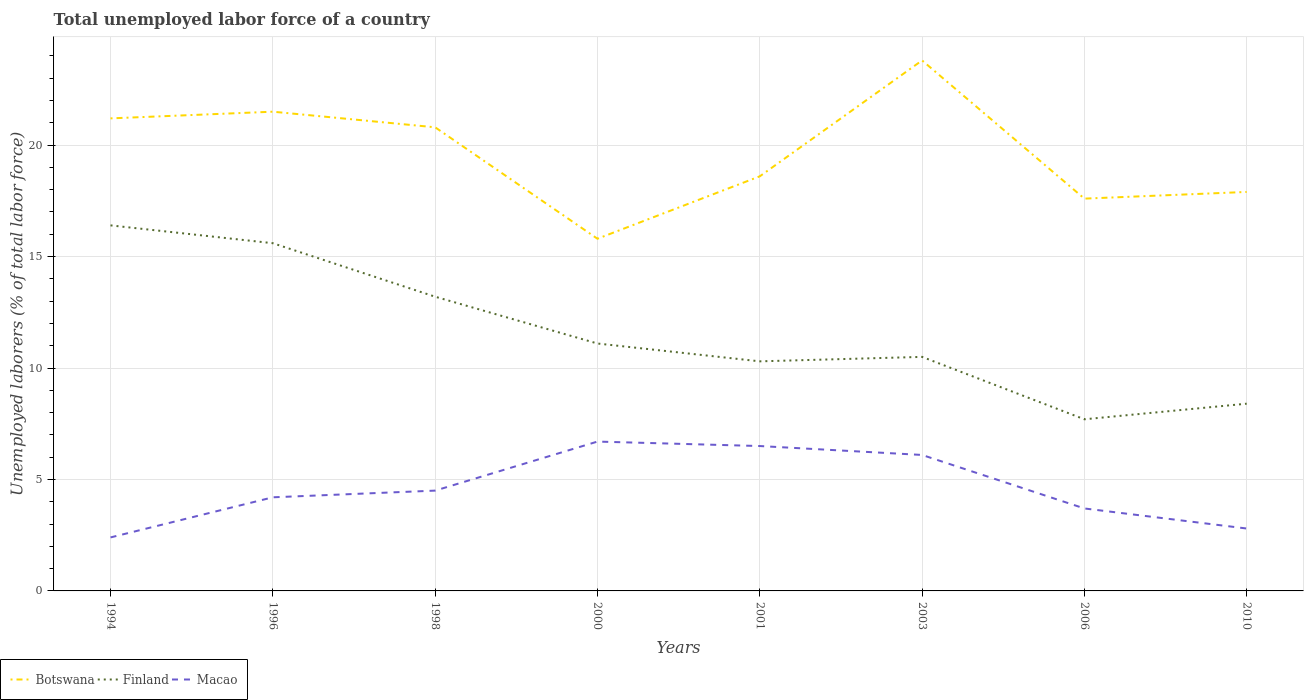Across all years, what is the maximum total unemployed labor force in Macao?
Provide a short and direct response. 2.4. What is the total total unemployed labor force in Botswana in the graph?
Your answer should be very brief. -2.1. What is the difference between the highest and the second highest total unemployed labor force in Finland?
Keep it short and to the point. 8.7. What is the difference between two consecutive major ticks on the Y-axis?
Keep it short and to the point. 5. Are the values on the major ticks of Y-axis written in scientific E-notation?
Offer a terse response. No. Where does the legend appear in the graph?
Ensure brevity in your answer.  Bottom left. What is the title of the graph?
Provide a succinct answer. Total unemployed labor force of a country. What is the label or title of the X-axis?
Your answer should be very brief. Years. What is the label or title of the Y-axis?
Your answer should be very brief. Unemployed laborers (% of total labor force). What is the Unemployed laborers (% of total labor force) of Botswana in 1994?
Offer a terse response. 21.2. What is the Unemployed laborers (% of total labor force) in Finland in 1994?
Offer a terse response. 16.4. What is the Unemployed laborers (% of total labor force) of Macao in 1994?
Give a very brief answer. 2.4. What is the Unemployed laborers (% of total labor force) of Finland in 1996?
Your answer should be compact. 15.6. What is the Unemployed laborers (% of total labor force) in Macao in 1996?
Give a very brief answer. 4.2. What is the Unemployed laborers (% of total labor force) of Botswana in 1998?
Offer a very short reply. 20.8. What is the Unemployed laborers (% of total labor force) in Finland in 1998?
Ensure brevity in your answer.  13.2. What is the Unemployed laborers (% of total labor force) of Macao in 1998?
Provide a succinct answer. 4.5. What is the Unemployed laborers (% of total labor force) in Botswana in 2000?
Offer a very short reply. 15.8. What is the Unemployed laborers (% of total labor force) of Finland in 2000?
Give a very brief answer. 11.1. What is the Unemployed laborers (% of total labor force) of Macao in 2000?
Offer a terse response. 6.7. What is the Unemployed laborers (% of total labor force) in Botswana in 2001?
Provide a short and direct response. 18.6. What is the Unemployed laborers (% of total labor force) of Finland in 2001?
Provide a succinct answer. 10.3. What is the Unemployed laborers (% of total labor force) in Macao in 2001?
Provide a short and direct response. 6.5. What is the Unemployed laborers (% of total labor force) in Botswana in 2003?
Your answer should be compact. 23.8. What is the Unemployed laborers (% of total labor force) in Macao in 2003?
Provide a succinct answer. 6.1. What is the Unemployed laborers (% of total labor force) of Botswana in 2006?
Offer a very short reply. 17.6. What is the Unemployed laborers (% of total labor force) of Finland in 2006?
Make the answer very short. 7.7. What is the Unemployed laborers (% of total labor force) of Macao in 2006?
Give a very brief answer. 3.7. What is the Unemployed laborers (% of total labor force) of Botswana in 2010?
Your answer should be compact. 17.9. What is the Unemployed laborers (% of total labor force) in Finland in 2010?
Your answer should be very brief. 8.4. What is the Unemployed laborers (% of total labor force) of Macao in 2010?
Provide a short and direct response. 2.8. Across all years, what is the maximum Unemployed laborers (% of total labor force) of Botswana?
Provide a succinct answer. 23.8. Across all years, what is the maximum Unemployed laborers (% of total labor force) of Finland?
Give a very brief answer. 16.4. Across all years, what is the maximum Unemployed laborers (% of total labor force) in Macao?
Make the answer very short. 6.7. Across all years, what is the minimum Unemployed laborers (% of total labor force) in Botswana?
Give a very brief answer. 15.8. Across all years, what is the minimum Unemployed laborers (% of total labor force) of Finland?
Provide a succinct answer. 7.7. Across all years, what is the minimum Unemployed laborers (% of total labor force) in Macao?
Offer a terse response. 2.4. What is the total Unemployed laborers (% of total labor force) of Botswana in the graph?
Offer a very short reply. 157.2. What is the total Unemployed laborers (% of total labor force) of Finland in the graph?
Offer a very short reply. 93.2. What is the total Unemployed laborers (% of total labor force) of Macao in the graph?
Provide a short and direct response. 36.9. What is the difference between the Unemployed laborers (% of total labor force) of Finland in 1994 and that in 1996?
Your answer should be very brief. 0.8. What is the difference between the Unemployed laborers (% of total labor force) of Macao in 1994 and that in 1996?
Your answer should be compact. -1.8. What is the difference between the Unemployed laborers (% of total labor force) in Botswana in 1994 and that in 1998?
Keep it short and to the point. 0.4. What is the difference between the Unemployed laborers (% of total labor force) of Finland in 1994 and that in 1998?
Give a very brief answer. 3.2. What is the difference between the Unemployed laborers (% of total labor force) of Macao in 1994 and that in 1998?
Your response must be concise. -2.1. What is the difference between the Unemployed laborers (% of total labor force) of Macao in 1994 and that in 2000?
Ensure brevity in your answer.  -4.3. What is the difference between the Unemployed laborers (% of total labor force) of Botswana in 1994 and that in 2001?
Provide a short and direct response. 2.6. What is the difference between the Unemployed laborers (% of total labor force) in Botswana in 1994 and that in 2003?
Give a very brief answer. -2.6. What is the difference between the Unemployed laborers (% of total labor force) in Macao in 1994 and that in 2003?
Offer a very short reply. -3.7. What is the difference between the Unemployed laborers (% of total labor force) in Finland in 1994 and that in 2006?
Provide a succinct answer. 8.7. What is the difference between the Unemployed laborers (% of total labor force) of Botswana in 1994 and that in 2010?
Offer a terse response. 3.3. What is the difference between the Unemployed laborers (% of total labor force) of Finland in 1994 and that in 2010?
Provide a succinct answer. 8. What is the difference between the Unemployed laborers (% of total labor force) of Macao in 1994 and that in 2010?
Make the answer very short. -0.4. What is the difference between the Unemployed laborers (% of total labor force) in Botswana in 1996 and that in 1998?
Keep it short and to the point. 0.7. What is the difference between the Unemployed laborers (% of total labor force) of Finland in 1996 and that in 1998?
Give a very brief answer. 2.4. What is the difference between the Unemployed laborers (% of total labor force) in Macao in 1996 and that in 1998?
Keep it short and to the point. -0.3. What is the difference between the Unemployed laborers (% of total labor force) of Botswana in 1996 and that in 2000?
Offer a very short reply. 5.7. What is the difference between the Unemployed laborers (% of total labor force) in Finland in 1996 and that in 2000?
Provide a succinct answer. 4.5. What is the difference between the Unemployed laborers (% of total labor force) of Macao in 1996 and that in 2000?
Ensure brevity in your answer.  -2.5. What is the difference between the Unemployed laborers (% of total labor force) of Botswana in 1996 and that in 2001?
Your response must be concise. 2.9. What is the difference between the Unemployed laborers (% of total labor force) of Finland in 1996 and that in 2006?
Your answer should be very brief. 7.9. What is the difference between the Unemployed laborers (% of total labor force) of Botswana in 1996 and that in 2010?
Your answer should be compact. 3.6. What is the difference between the Unemployed laborers (% of total labor force) of Macao in 1996 and that in 2010?
Offer a terse response. 1.4. What is the difference between the Unemployed laborers (% of total labor force) of Macao in 1998 and that in 2000?
Ensure brevity in your answer.  -2.2. What is the difference between the Unemployed laborers (% of total labor force) of Finland in 1998 and that in 2001?
Give a very brief answer. 2.9. What is the difference between the Unemployed laborers (% of total labor force) of Finland in 1998 and that in 2003?
Provide a succinct answer. 2.7. What is the difference between the Unemployed laborers (% of total labor force) in Botswana in 1998 and that in 2006?
Give a very brief answer. 3.2. What is the difference between the Unemployed laborers (% of total labor force) in Finland in 1998 and that in 2006?
Ensure brevity in your answer.  5.5. What is the difference between the Unemployed laborers (% of total labor force) in Macao in 1998 and that in 2006?
Ensure brevity in your answer.  0.8. What is the difference between the Unemployed laborers (% of total labor force) in Finland in 1998 and that in 2010?
Make the answer very short. 4.8. What is the difference between the Unemployed laborers (% of total labor force) of Macao in 1998 and that in 2010?
Your answer should be compact. 1.7. What is the difference between the Unemployed laborers (% of total labor force) in Botswana in 2000 and that in 2003?
Offer a terse response. -8. What is the difference between the Unemployed laborers (% of total labor force) in Finland in 2000 and that in 2003?
Your response must be concise. 0.6. What is the difference between the Unemployed laborers (% of total labor force) of Botswana in 2000 and that in 2006?
Keep it short and to the point. -1.8. What is the difference between the Unemployed laborers (% of total labor force) of Macao in 2000 and that in 2006?
Offer a very short reply. 3. What is the difference between the Unemployed laborers (% of total labor force) in Botswana in 2000 and that in 2010?
Your answer should be very brief. -2.1. What is the difference between the Unemployed laborers (% of total labor force) of Finland in 2000 and that in 2010?
Provide a short and direct response. 2.7. What is the difference between the Unemployed laborers (% of total labor force) in Macao in 2000 and that in 2010?
Ensure brevity in your answer.  3.9. What is the difference between the Unemployed laborers (% of total labor force) in Botswana in 2001 and that in 2003?
Keep it short and to the point. -5.2. What is the difference between the Unemployed laborers (% of total labor force) of Finland in 2001 and that in 2003?
Make the answer very short. -0.2. What is the difference between the Unemployed laborers (% of total labor force) of Macao in 2001 and that in 2003?
Keep it short and to the point. 0.4. What is the difference between the Unemployed laborers (% of total labor force) in Finland in 2001 and that in 2006?
Ensure brevity in your answer.  2.6. What is the difference between the Unemployed laborers (% of total labor force) in Macao in 2003 and that in 2010?
Ensure brevity in your answer.  3.3. What is the difference between the Unemployed laborers (% of total labor force) of Finland in 2006 and that in 2010?
Your response must be concise. -0.7. What is the difference between the Unemployed laborers (% of total labor force) of Macao in 2006 and that in 2010?
Offer a terse response. 0.9. What is the difference between the Unemployed laborers (% of total labor force) in Finland in 1994 and the Unemployed laborers (% of total labor force) in Macao in 1996?
Make the answer very short. 12.2. What is the difference between the Unemployed laborers (% of total labor force) of Botswana in 1994 and the Unemployed laborers (% of total labor force) of Macao in 1998?
Offer a very short reply. 16.7. What is the difference between the Unemployed laborers (% of total labor force) in Botswana in 1994 and the Unemployed laborers (% of total labor force) in Finland in 2000?
Keep it short and to the point. 10.1. What is the difference between the Unemployed laborers (% of total labor force) of Finland in 1994 and the Unemployed laborers (% of total labor force) of Macao in 2000?
Make the answer very short. 9.7. What is the difference between the Unemployed laborers (% of total labor force) of Botswana in 1994 and the Unemployed laborers (% of total labor force) of Macao in 2001?
Your answer should be compact. 14.7. What is the difference between the Unemployed laborers (% of total labor force) of Botswana in 1994 and the Unemployed laborers (% of total labor force) of Finland in 2003?
Provide a succinct answer. 10.7. What is the difference between the Unemployed laborers (% of total labor force) in Botswana in 1994 and the Unemployed laborers (% of total labor force) in Macao in 2003?
Your answer should be compact. 15.1. What is the difference between the Unemployed laborers (% of total labor force) of Finland in 1994 and the Unemployed laborers (% of total labor force) of Macao in 2003?
Keep it short and to the point. 10.3. What is the difference between the Unemployed laborers (% of total labor force) of Finland in 1994 and the Unemployed laborers (% of total labor force) of Macao in 2006?
Offer a terse response. 12.7. What is the difference between the Unemployed laborers (% of total labor force) in Botswana in 1994 and the Unemployed laborers (% of total labor force) in Finland in 2010?
Ensure brevity in your answer.  12.8. What is the difference between the Unemployed laborers (% of total labor force) in Botswana in 1994 and the Unemployed laborers (% of total labor force) in Macao in 2010?
Your answer should be very brief. 18.4. What is the difference between the Unemployed laborers (% of total labor force) in Botswana in 1996 and the Unemployed laborers (% of total labor force) in Finland in 2000?
Offer a terse response. 10.4. What is the difference between the Unemployed laborers (% of total labor force) in Finland in 1996 and the Unemployed laborers (% of total labor force) in Macao in 2000?
Keep it short and to the point. 8.9. What is the difference between the Unemployed laborers (% of total labor force) in Finland in 1996 and the Unemployed laborers (% of total labor force) in Macao in 2001?
Your answer should be very brief. 9.1. What is the difference between the Unemployed laborers (% of total labor force) in Botswana in 1996 and the Unemployed laborers (% of total labor force) in Finland in 2003?
Offer a very short reply. 11. What is the difference between the Unemployed laborers (% of total labor force) of Finland in 1996 and the Unemployed laborers (% of total labor force) of Macao in 2003?
Your answer should be compact. 9.5. What is the difference between the Unemployed laborers (% of total labor force) in Botswana in 1996 and the Unemployed laborers (% of total labor force) in Macao in 2006?
Ensure brevity in your answer.  17.8. What is the difference between the Unemployed laborers (% of total labor force) of Botswana in 1996 and the Unemployed laborers (% of total labor force) of Finland in 2010?
Keep it short and to the point. 13.1. What is the difference between the Unemployed laborers (% of total labor force) of Finland in 1996 and the Unemployed laborers (% of total labor force) of Macao in 2010?
Your response must be concise. 12.8. What is the difference between the Unemployed laborers (% of total labor force) in Botswana in 1998 and the Unemployed laborers (% of total labor force) in Finland in 2000?
Your answer should be very brief. 9.7. What is the difference between the Unemployed laborers (% of total labor force) in Finland in 1998 and the Unemployed laborers (% of total labor force) in Macao in 2000?
Your answer should be compact. 6.5. What is the difference between the Unemployed laborers (% of total labor force) in Botswana in 1998 and the Unemployed laborers (% of total labor force) in Macao in 2001?
Make the answer very short. 14.3. What is the difference between the Unemployed laborers (% of total labor force) in Botswana in 1998 and the Unemployed laborers (% of total labor force) in Finland in 2003?
Give a very brief answer. 10.3. What is the difference between the Unemployed laborers (% of total labor force) of Finland in 1998 and the Unemployed laborers (% of total labor force) of Macao in 2003?
Keep it short and to the point. 7.1. What is the difference between the Unemployed laborers (% of total labor force) in Botswana in 1998 and the Unemployed laborers (% of total labor force) in Finland in 2010?
Give a very brief answer. 12.4. What is the difference between the Unemployed laborers (% of total labor force) of Botswana in 1998 and the Unemployed laborers (% of total labor force) of Macao in 2010?
Provide a succinct answer. 18. What is the difference between the Unemployed laborers (% of total labor force) in Botswana in 2000 and the Unemployed laborers (% of total labor force) in Macao in 2001?
Ensure brevity in your answer.  9.3. What is the difference between the Unemployed laborers (% of total labor force) in Botswana in 2000 and the Unemployed laborers (% of total labor force) in Finland in 2003?
Offer a terse response. 5.3. What is the difference between the Unemployed laborers (% of total labor force) in Botswana in 2000 and the Unemployed laborers (% of total labor force) in Macao in 2003?
Make the answer very short. 9.7. What is the difference between the Unemployed laborers (% of total labor force) in Finland in 2000 and the Unemployed laborers (% of total labor force) in Macao in 2003?
Give a very brief answer. 5. What is the difference between the Unemployed laborers (% of total labor force) of Botswana in 2000 and the Unemployed laborers (% of total labor force) of Finland in 2006?
Make the answer very short. 8.1. What is the difference between the Unemployed laborers (% of total labor force) in Botswana in 2000 and the Unemployed laborers (% of total labor force) in Macao in 2006?
Your answer should be very brief. 12.1. What is the difference between the Unemployed laborers (% of total labor force) of Finland in 2000 and the Unemployed laborers (% of total labor force) of Macao in 2006?
Your answer should be very brief. 7.4. What is the difference between the Unemployed laborers (% of total labor force) in Botswana in 2000 and the Unemployed laborers (% of total labor force) in Finland in 2010?
Offer a very short reply. 7.4. What is the difference between the Unemployed laborers (% of total labor force) in Botswana in 2000 and the Unemployed laborers (% of total labor force) in Macao in 2010?
Keep it short and to the point. 13. What is the difference between the Unemployed laborers (% of total labor force) of Botswana in 2001 and the Unemployed laborers (% of total labor force) of Macao in 2003?
Your response must be concise. 12.5. What is the difference between the Unemployed laborers (% of total labor force) of Finland in 2001 and the Unemployed laborers (% of total labor force) of Macao in 2003?
Your answer should be compact. 4.2. What is the difference between the Unemployed laborers (% of total labor force) in Botswana in 2001 and the Unemployed laborers (% of total labor force) in Finland in 2006?
Ensure brevity in your answer.  10.9. What is the difference between the Unemployed laborers (% of total labor force) in Botswana in 2001 and the Unemployed laborers (% of total labor force) in Macao in 2006?
Make the answer very short. 14.9. What is the difference between the Unemployed laborers (% of total labor force) of Botswana in 2001 and the Unemployed laborers (% of total labor force) of Macao in 2010?
Offer a very short reply. 15.8. What is the difference between the Unemployed laborers (% of total labor force) of Botswana in 2003 and the Unemployed laborers (% of total labor force) of Macao in 2006?
Your answer should be very brief. 20.1. What is the difference between the Unemployed laborers (% of total labor force) in Botswana in 2006 and the Unemployed laborers (% of total labor force) in Macao in 2010?
Provide a short and direct response. 14.8. What is the average Unemployed laborers (% of total labor force) in Botswana per year?
Offer a terse response. 19.65. What is the average Unemployed laborers (% of total labor force) of Finland per year?
Keep it short and to the point. 11.65. What is the average Unemployed laborers (% of total labor force) of Macao per year?
Your response must be concise. 4.61. In the year 1994, what is the difference between the Unemployed laborers (% of total labor force) in Botswana and Unemployed laborers (% of total labor force) in Finland?
Offer a very short reply. 4.8. In the year 1994, what is the difference between the Unemployed laborers (% of total labor force) of Finland and Unemployed laborers (% of total labor force) of Macao?
Your response must be concise. 14. In the year 1996, what is the difference between the Unemployed laborers (% of total labor force) of Botswana and Unemployed laborers (% of total labor force) of Finland?
Your response must be concise. 5.9. In the year 1998, what is the difference between the Unemployed laborers (% of total labor force) in Botswana and Unemployed laborers (% of total labor force) in Macao?
Your response must be concise. 16.3. In the year 1998, what is the difference between the Unemployed laborers (% of total labor force) in Finland and Unemployed laborers (% of total labor force) in Macao?
Provide a succinct answer. 8.7. In the year 2000, what is the difference between the Unemployed laborers (% of total labor force) of Botswana and Unemployed laborers (% of total labor force) of Finland?
Give a very brief answer. 4.7. In the year 2000, what is the difference between the Unemployed laborers (% of total labor force) of Botswana and Unemployed laborers (% of total labor force) of Macao?
Provide a succinct answer. 9.1. In the year 2001, what is the difference between the Unemployed laborers (% of total labor force) of Finland and Unemployed laborers (% of total labor force) of Macao?
Your answer should be very brief. 3.8. In the year 2003, what is the difference between the Unemployed laborers (% of total labor force) in Finland and Unemployed laborers (% of total labor force) in Macao?
Provide a succinct answer. 4.4. In the year 2006, what is the difference between the Unemployed laborers (% of total labor force) in Botswana and Unemployed laborers (% of total labor force) in Finland?
Make the answer very short. 9.9. In the year 2010, what is the difference between the Unemployed laborers (% of total labor force) in Botswana and Unemployed laborers (% of total labor force) in Macao?
Offer a very short reply. 15.1. In the year 2010, what is the difference between the Unemployed laborers (% of total labor force) of Finland and Unemployed laborers (% of total labor force) of Macao?
Ensure brevity in your answer.  5.6. What is the ratio of the Unemployed laborers (% of total labor force) of Botswana in 1994 to that in 1996?
Keep it short and to the point. 0.99. What is the ratio of the Unemployed laborers (% of total labor force) of Finland in 1994 to that in 1996?
Your answer should be compact. 1.05. What is the ratio of the Unemployed laborers (% of total labor force) of Botswana in 1994 to that in 1998?
Provide a short and direct response. 1.02. What is the ratio of the Unemployed laborers (% of total labor force) in Finland in 1994 to that in 1998?
Offer a very short reply. 1.24. What is the ratio of the Unemployed laborers (% of total labor force) of Macao in 1994 to that in 1998?
Make the answer very short. 0.53. What is the ratio of the Unemployed laborers (% of total labor force) of Botswana in 1994 to that in 2000?
Ensure brevity in your answer.  1.34. What is the ratio of the Unemployed laborers (% of total labor force) of Finland in 1994 to that in 2000?
Your answer should be compact. 1.48. What is the ratio of the Unemployed laborers (% of total labor force) in Macao in 1994 to that in 2000?
Make the answer very short. 0.36. What is the ratio of the Unemployed laborers (% of total labor force) of Botswana in 1994 to that in 2001?
Ensure brevity in your answer.  1.14. What is the ratio of the Unemployed laborers (% of total labor force) in Finland in 1994 to that in 2001?
Provide a succinct answer. 1.59. What is the ratio of the Unemployed laborers (% of total labor force) in Macao in 1994 to that in 2001?
Provide a short and direct response. 0.37. What is the ratio of the Unemployed laborers (% of total labor force) of Botswana in 1994 to that in 2003?
Your answer should be compact. 0.89. What is the ratio of the Unemployed laborers (% of total labor force) of Finland in 1994 to that in 2003?
Offer a very short reply. 1.56. What is the ratio of the Unemployed laborers (% of total labor force) of Macao in 1994 to that in 2003?
Offer a terse response. 0.39. What is the ratio of the Unemployed laborers (% of total labor force) in Botswana in 1994 to that in 2006?
Make the answer very short. 1.2. What is the ratio of the Unemployed laborers (% of total labor force) in Finland in 1994 to that in 2006?
Keep it short and to the point. 2.13. What is the ratio of the Unemployed laborers (% of total labor force) of Macao in 1994 to that in 2006?
Offer a terse response. 0.65. What is the ratio of the Unemployed laborers (% of total labor force) of Botswana in 1994 to that in 2010?
Provide a short and direct response. 1.18. What is the ratio of the Unemployed laborers (% of total labor force) in Finland in 1994 to that in 2010?
Ensure brevity in your answer.  1.95. What is the ratio of the Unemployed laborers (% of total labor force) of Botswana in 1996 to that in 1998?
Provide a short and direct response. 1.03. What is the ratio of the Unemployed laborers (% of total labor force) of Finland in 1996 to that in 1998?
Your answer should be compact. 1.18. What is the ratio of the Unemployed laborers (% of total labor force) of Botswana in 1996 to that in 2000?
Provide a short and direct response. 1.36. What is the ratio of the Unemployed laborers (% of total labor force) in Finland in 1996 to that in 2000?
Keep it short and to the point. 1.41. What is the ratio of the Unemployed laborers (% of total labor force) of Macao in 1996 to that in 2000?
Give a very brief answer. 0.63. What is the ratio of the Unemployed laborers (% of total labor force) of Botswana in 1996 to that in 2001?
Offer a terse response. 1.16. What is the ratio of the Unemployed laborers (% of total labor force) in Finland in 1996 to that in 2001?
Your answer should be very brief. 1.51. What is the ratio of the Unemployed laborers (% of total labor force) of Macao in 1996 to that in 2001?
Your response must be concise. 0.65. What is the ratio of the Unemployed laborers (% of total labor force) of Botswana in 1996 to that in 2003?
Make the answer very short. 0.9. What is the ratio of the Unemployed laborers (% of total labor force) in Finland in 1996 to that in 2003?
Your answer should be very brief. 1.49. What is the ratio of the Unemployed laborers (% of total labor force) of Macao in 1996 to that in 2003?
Provide a short and direct response. 0.69. What is the ratio of the Unemployed laborers (% of total labor force) in Botswana in 1996 to that in 2006?
Make the answer very short. 1.22. What is the ratio of the Unemployed laborers (% of total labor force) in Finland in 1996 to that in 2006?
Keep it short and to the point. 2.03. What is the ratio of the Unemployed laborers (% of total labor force) of Macao in 1996 to that in 2006?
Provide a succinct answer. 1.14. What is the ratio of the Unemployed laborers (% of total labor force) of Botswana in 1996 to that in 2010?
Offer a terse response. 1.2. What is the ratio of the Unemployed laborers (% of total labor force) in Finland in 1996 to that in 2010?
Keep it short and to the point. 1.86. What is the ratio of the Unemployed laborers (% of total labor force) of Macao in 1996 to that in 2010?
Offer a very short reply. 1.5. What is the ratio of the Unemployed laborers (% of total labor force) of Botswana in 1998 to that in 2000?
Ensure brevity in your answer.  1.32. What is the ratio of the Unemployed laborers (% of total labor force) of Finland in 1998 to that in 2000?
Make the answer very short. 1.19. What is the ratio of the Unemployed laborers (% of total labor force) in Macao in 1998 to that in 2000?
Keep it short and to the point. 0.67. What is the ratio of the Unemployed laborers (% of total labor force) of Botswana in 1998 to that in 2001?
Ensure brevity in your answer.  1.12. What is the ratio of the Unemployed laborers (% of total labor force) in Finland in 1998 to that in 2001?
Give a very brief answer. 1.28. What is the ratio of the Unemployed laborers (% of total labor force) of Macao in 1998 to that in 2001?
Offer a very short reply. 0.69. What is the ratio of the Unemployed laborers (% of total labor force) of Botswana in 1998 to that in 2003?
Your answer should be compact. 0.87. What is the ratio of the Unemployed laborers (% of total labor force) in Finland in 1998 to that in 2003?
Your response must be concise. 1.26. What is the ratio of the Unemployed laborers (% of total labor force) of Macao in 1998 to that in 2003?
Provide a short and direct response. 0.74. What is the ratio of the Unemployed laborers (% of total labor force) of Botswana in 1998 to that in 2006?
Give a very brief answer. 1.18. What is the ratio of the Unemployed laborers (% of total labor force) in Finland in 1998 to that in 2006?
Your answer should be compact. 1.71. What is the ratio of the Unemployed laborers (% of total labor force) of Macao in 1998 to that in 2006?
Give a very brief answer. 1.22. What is the ratio of the Unemployed laborers (% of total labor force) in Botswana in 1998 to that in 2010?
Provide a succinct answer. 1.16. What is the ratio of the Unemployed laborers (% of total labor force) of Finland in 1998 to that in 2010?
Provide a succinct answer. 1.57. What is the ratio of the Unemployed laborers (% of total labor force) of Macao in 1998 to that in 2010?
Make the answer very short. 1.61. What is the ratio of the Unemployed laborers (% of total labor force) in Botswana in 2000 to that in 2001?
Keep it short and to the point. 0.85. What is the ratio of the Unemployed laborers (% of total labor force) of Finland in 2000 to that in 2001?
Give a very brief answer. 1.08. What is the ratio of the Unemployed laborers (% of total labor force) of Macao in 2000 to that in 2001?
Give a very brief answer. 1.03. What is the ratio of the Unemployed laborers (% of total labor force) of Botswana in 2000 to that in 2003?
Ensure brevity in your answer.  0.66. What is the ratio of the Unemployed laborers (% of total labor force) of Finland in 2000 to that in 2003?
Your response must be concise. 1.06. What is the ratio of the Unemployed laborers (% of total labor force) in Macao in 2000 to that in 2003?
Make the answer very short. 1.1. What is the ratio of the Unemployed laborers (% of total labor force) of Botswana in 2000 to that in 2006?
Offer a very short reply. 0.9. What is the ratio of the Unemployed laborers (% of total labor force) of Finland in 2000 to that in 2006?
Offer a terse response. 1.44. What is the ratio of the Unemployed laborers (% of total labor force) of Macao in 2000 to that in 2006?
Your response must be concise. 1.81. What is the ratio of the Unemployed laborers (% of total labor force) of Botswana in 2000 to that in 2010?
Make the answer very short. 0.88. What is the ratio of the Unemployed laborers (% of total labor force) of Finland in 2000 to that in 2010?
Make the answer very short. 1.32. What is the ratio of the Unemployed laborers (% of total labor force) of Macao in 2000 to that in 2010?
Your answer should be compact. 2.39. What is the ratio of the Unemployed laborers (% of total labor force) of Botswana in 2001 to that in 2003?
Keep it short and to the point. 0.78. What is the ratio of the Unemployed laborers (% of total labor force) in Macao in 2001 to that in 2003?
Your answer should be very brief. 1.07. What is the ratio of the Unemployed laborers (% of total labor force) of Botswana in 2001 to that in 2006?
Keep it short and to the point. 1.06. What is the ratio of the Unemployed laborers (% of total labor force) in Finland in 2001 to that in 2006?
Offer a terse response. 1.34. What is the ratio of the Unemployed laborers (% of total labor force) in Macao in 2001 to that in 2006?
Offer a very short reply. 1.76. What is the ratio of the Unemployed laborers (% of total labor force) in Botswana in 2001 to that in 2010?
Provide a short and direct response. 1.04. What is the ratio of the Unemployed laborers (% of total labor force) of Finland in 2001 to that in 2010?
Keep it short and to the point. 1.23. What is the ratio of the Unemployed laborers (% of total labor force) of Macao in 2001 to that in 2010?
Your response must be concise. 2.32. What is the ratio of the Unemployed laborers (% of total labor force) of Botswana in 2003 to that in 2006?
Your response must be concise. 1.35. What is the ratio of the Unemployed laborers (% of total labor force) in Finland in 2003 to that in 2006?
Provide a short and direct response. 1.36. What is the ratio of the Unemployed laborers (% of total labor force) of Macao in 2003 to that in 2006?
Your response must be concise. 1.65. What is the ratio of the Unemployed laborers (% of total labor force) in Botswana in 2003 to that in 2010?
Keep it short and to the point. 1.33. What is the ratio of the Unemployed laborers (% of total labor force) of Macao in 2003 to that in 2010?
Your answer should be compact. 2.18. What is the ratio of the Unemployed laborers (% of total labor force) of Botswana in 2006 to that in 2010?
Provide a succinct answer. 0.98. What is the ratio of the Unemployed laborers (% of total labor force) in Finland in 2006 to that in 2010?
Offer a terse response. 0.92. What is the ratio of the Unemployed laborers (% of total labor force) of Macao in 2006 to that in 2010?
Provide a succinct answer. 1.32. What is the difference between the highest and the second highest Unemployed laborers (% of total labor force) of Botswana?
Your answer should be compact. 2.3. 